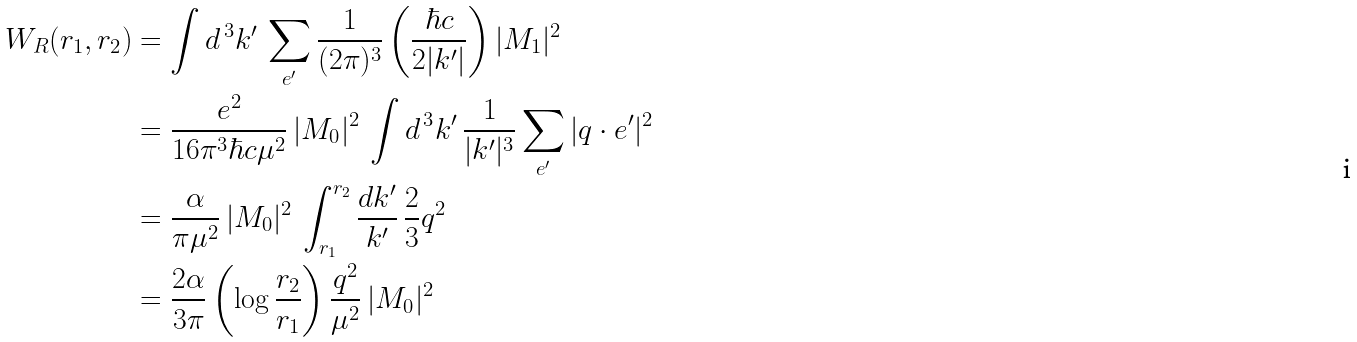<formula> <loc_0><loc_0><loc_500><loc_500>W _ { R } ( r _ { 1 } , r _ { 2 } ) & = \int d ^ { \, 3 } k ^ { \prime } \, \sum _ { e ^ { \prime } } \frac { 1 } { ( 2 \pi ) ^ { 3 } } \left ( \frac { \hbar { c } } { 2 | k ^ { \prime } | } \right ) | M _ { 1 } | ^ { 2 } \\ & = \frac { e ^ { 2 } } { 1 6 \pi ^ { 3 } \hbar { c } \mu ^ { 2 } } \, | M _ { 0 } | ^ { 2 } \, \int d ^ { \, 3 } k ^ { \prime } \, \frac { 1 } { | k ^ { \prime } | ^ { 3 } } \sum _ { e ^ { \prime } } | q \cdot e ^ { \prime } | ^ { 2 } \\ & = \frac { \alpha } { \pi \mu ^ { 2 } } \, | M _ { 0 } | ^ { 2 } \, \int _ { r _ { 1 } } ^ { r _ { 2 } } \frac { d k ^ { \prime } } { k ^ { \prime } } \, \frac { 2 } { 3 } q ^ { 2 } \\ & = \frac { 2 \alpha } { 3 \pi } \left ( \log \frac { r _ { 2 } } { r _ { 1 } } \right ) \frac { q ^ { 2 } } { \mu ^ { 2 } } \, | M _ { 0 } | ^ { 2 }</formula> 